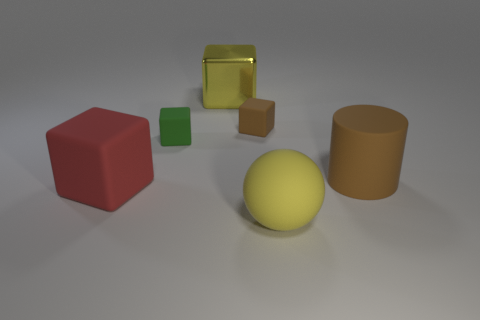There is a big thing that is the same color as the large metallic block; what is its material?
Give a very brief answer. Rubber. Is the size of the yellow ball that is on the left side of the brown rubber cylinder the same as the yellow shiny object?
Make the answer very short. Yes. How big is the thing that is to the left of the tiny brown thing and in front of the green cube?
Offer a terse response. Large. How many other things are there of the same material as the ball?
Offer a terse response. 4. What size is the object that is left of the tiny green cube?
Offer a terse response. Large. Does the large rubber ball have the same color as the metal cube?
Offer a very short reply. Yes. What number of tiny things are brown rubber cylinders or red rubber cubes?
Make the answer very short. 0. Is there any other thing of the same color as the large metallic cube?
Your response must be concise. Yes. Are there any tiny green blocks in front of the yellow rubber sphere?
Provide a succinct answer. No. There is a yellow object right of the large cube that is behind the large brown cylinder; what is its size?
Provide a succinct answer. Large. 